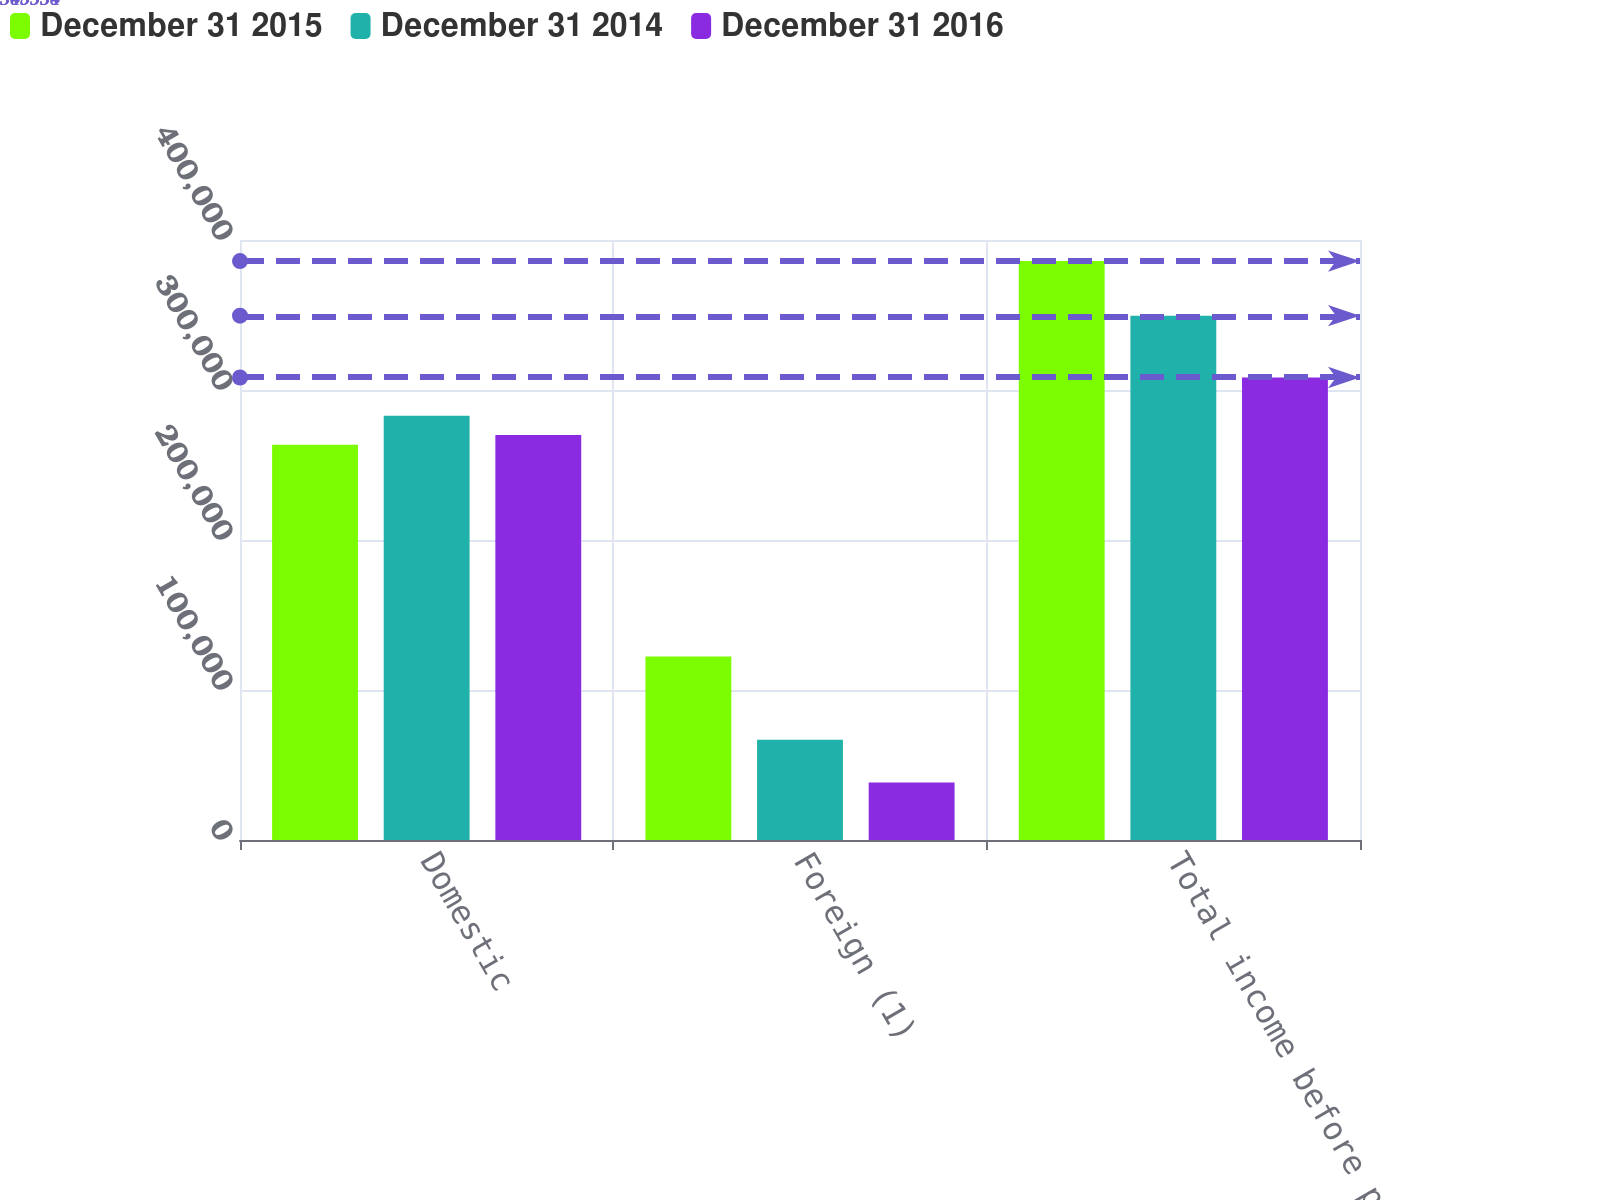Convert chart. <chart><loc_0><loc_0><loc_500><loc_500><stacked_bar_chart><ecel><fcel>Domestic<fcel>Foreign (1)<fcel>Total income before provision<nl><fcel>December 31 2015<fcel>263536<fcel>122402<fcel>385938<nl><fcel>December 31 2014<fcel>282764<fcel>66790<fcel>349554<nl><fcel>December 31 2016<fcel>269944<fcel>38394<fcel>308338<nl></chart> 